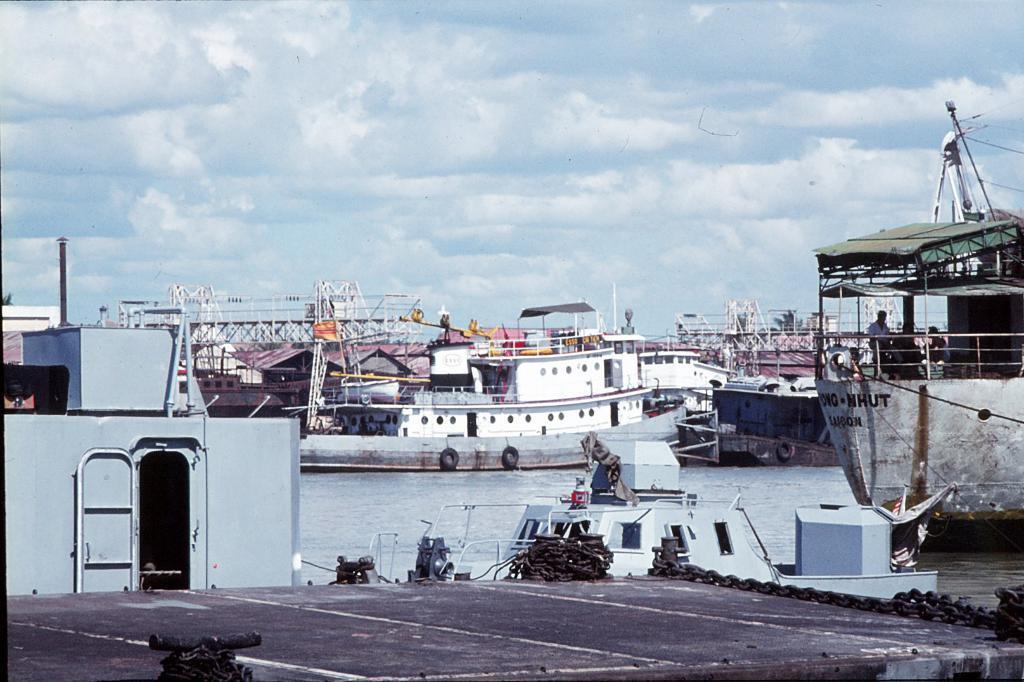How would you summarize this image in a sentence or two? In this image I can see the metal chains and many boats on the water. I can see two people sitting in one of the boat. In the background I can see the clouds and the sky. 